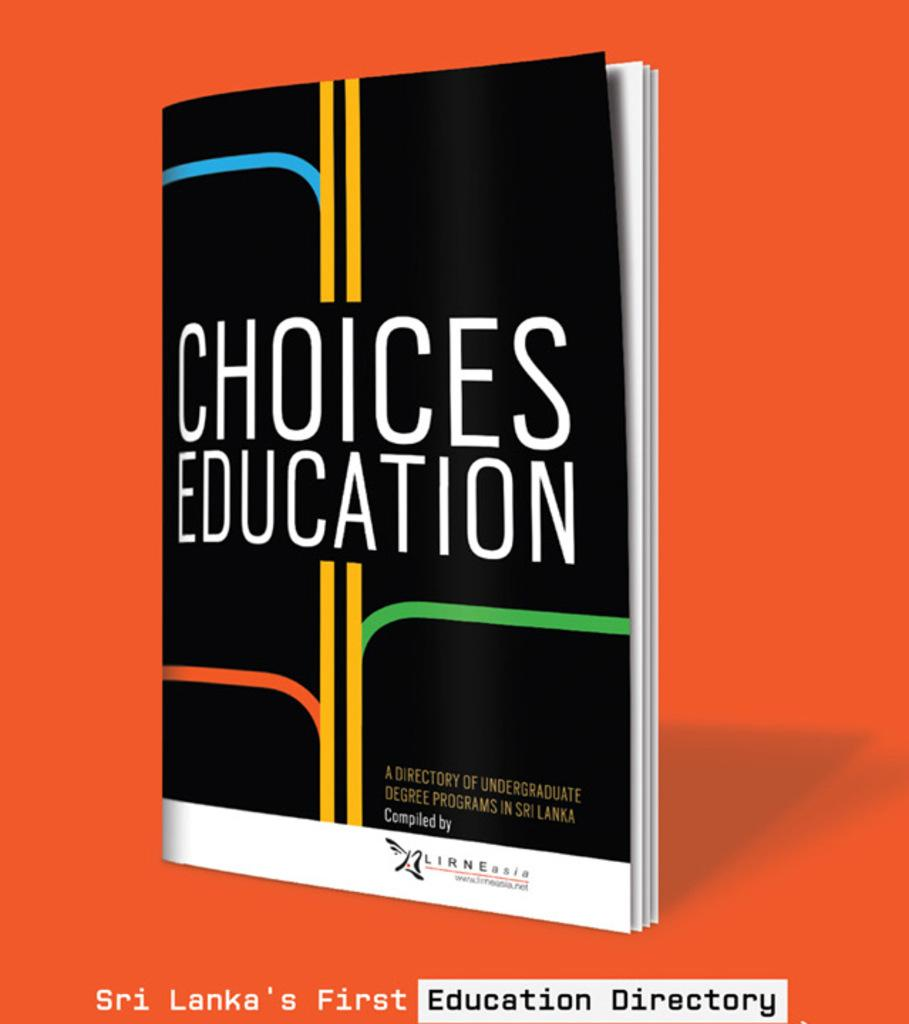Provide a one-sentence caption for the provided image. The cover of the book Choices Education, which is Shi Lanka's First Education Directory. 